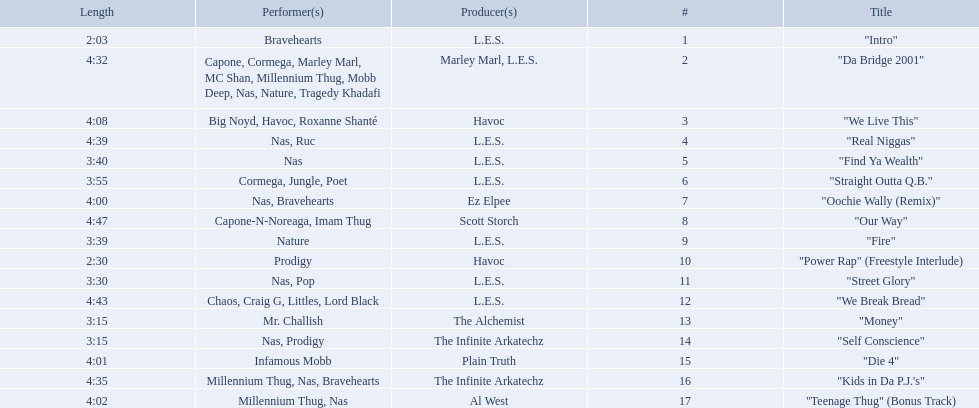What are all the songs on the album? "Intro", "Da Bridge 2001", "We Live This", "Real Niggas", "Find Ya Wealth", "Straight Outta Q.B.", "Oochie Wally (Remix)", "Our Way", "Fire", "Power Rap" (Freestyle Interlude), "Street Glory", "We Break Bread", "Money", "Self Conscience", "Die 4", "Kids in Da P.J.'s", "Teenage Thug" (Bonus Track). Which is the shortest? "Intro". How long is that song? 2:03. How long is each song? 2:03, 4:32, 4:08, 4:39, 3:40, 3:55, 4:00, 4:47, 3:39, 2:30, 3:30, 4:43, 3:15, 3:15, 4:01, 4:35, 4:02. Of those, which length is the shortest? 2:03. 